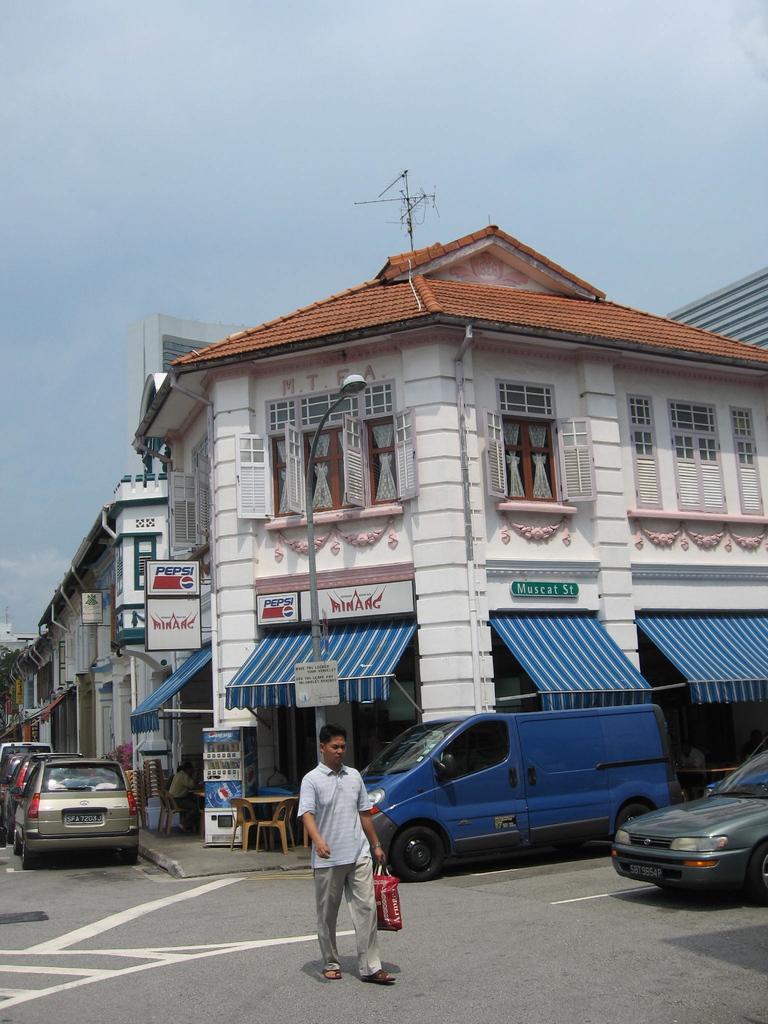Can you describe this image briefly? In this image there is a person holding a bag and walking on the street, there are name boards ,buildings, pole, lights, antenna, vehicles, sky. 